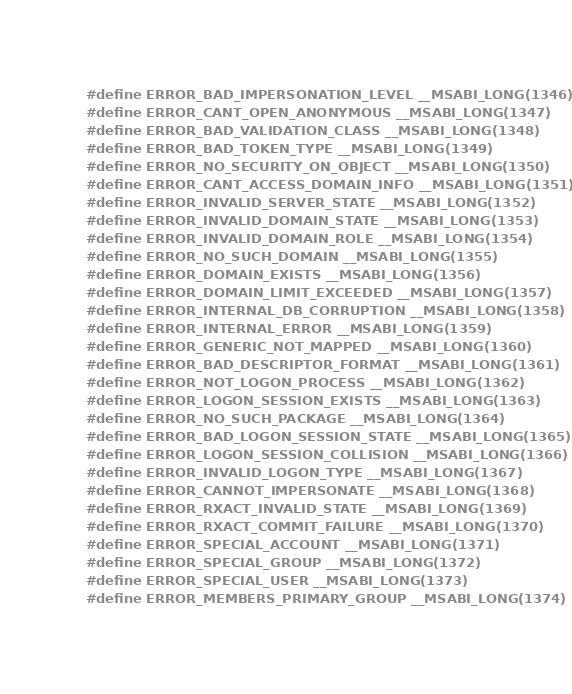Convert code to text. <code><loc_0><loc_0><loc_500><loc_500><_C_>#define ERROR_BAD_IMPERSONATION_LEVEL __MSABI_LONG(1346)
#define ERROR_CANT_OPEN_ANONYMOUS __MSABI_LONG(1347)
#define ERROR_BAD_VALIDATION_CLASS __MSABI_LONG(1348)
#define ERROR_BAD_TOKEN_TYPE __MSABI_LONG(1349)
#define ERROR_NO_SECURITY_ON_OBJECT __MSABI_LONG(1350)
#define ERROR_CANT_ACCESS_DOMAIN_INFO __MSABI_LONG(1351)
#define ERROR_INVALID_SERVER_STATE __MSABI_LONG(1352)
#define ERROR_INVALID_DOMAIN_STATE __MSABI_LONG(1353)
#define ERROR_INVALID_DOMAIN_ROLE __MSABI_LONG(1354)
#define ERROR_NO_SUCH_DOMAIN __MSABI_LONG(1355)
#define ERROR_DOMAIN_EXISTS __MSABI_LONG(1356)
#define ERROR_DOMAIN_LIMIT_EXCEEDED __MSABI_LONG(1357)
#define ERROR_INTERNAL_DB_CORRUPTION __MSABI_LONG(1358)
#define ERROR_INTERNAL_ERROR __MSABI_LONG(1359)
#define ERROR_GENERIC_NOT_MAPPED __MSABI_LONG(1360)
#define ERROR_BAD_DESCRIPTOR_FORMAT __MSABI_LONG(1361)
#define ERROR_NOT_LOGON_PROCESS __MSABI_LONG(1362)
#define ERROR_LOGON_SESSION_EXISTS __MSABI_LONG(1363)
#define ERROR_NO_SUCH_PACKAGE __MSABI_LONG(1364)
#define ERROR_BAD_LOGON_SESSION_STATE __MSABI_LONG(1365)
#define ERROR_LOGON_SESSION_COLLISION __MSABI_LONG(1366)
#define ERROR_INVALID_LOGON_TYPE __MSABI_LONG(1367)
#define ERROR_CANNOT_IMPERSONATE __MSABI_LONG(1368)
#define ERROR_RXACT_INVALID_STATE __MSABI_LONG(1369)
#define ERROR_RXACT_COMMIT_FAILURE __MSABI_LONG(1370)
#define ERROR_SPECIAL_ACCOUNT __MSABI_LONG(1371)
#define ERROR_SPECIAL_GROUP __MSABI_LONG(1372)
#define ERROR_SPECIAL_USER __MSABI_LONG(1373)
#define ERROR_MEMBERS_PRIMARY_GROUP __MSABI_LONG(1374)</code> 